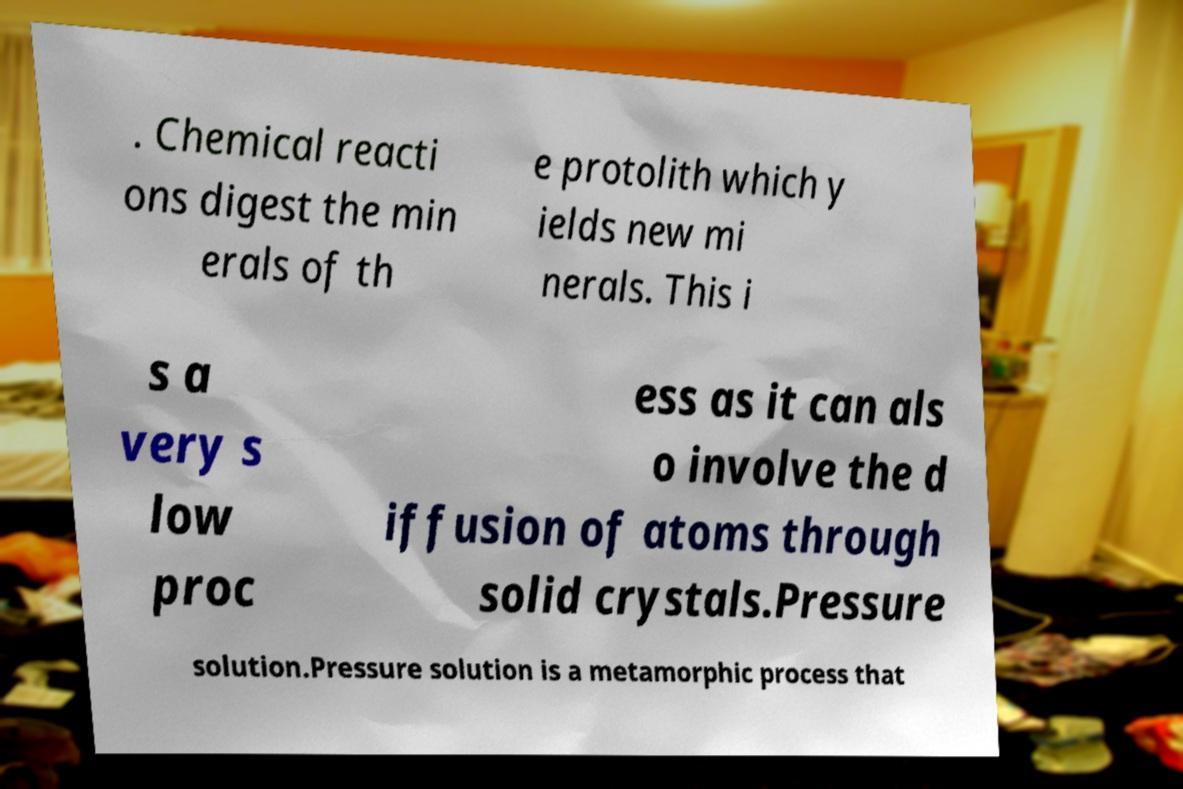There's text embedded in this image that I need extracted. Can you transcribe it verbatim? . Chemical reacti ons digest the min erals of th e protolith which y ields new mi nerals. This i s a very s low proc ess as it can als o involve the d iffusion of atoms through solid crystals.Pressure solution.Pressure solution is a metamorphic process that 